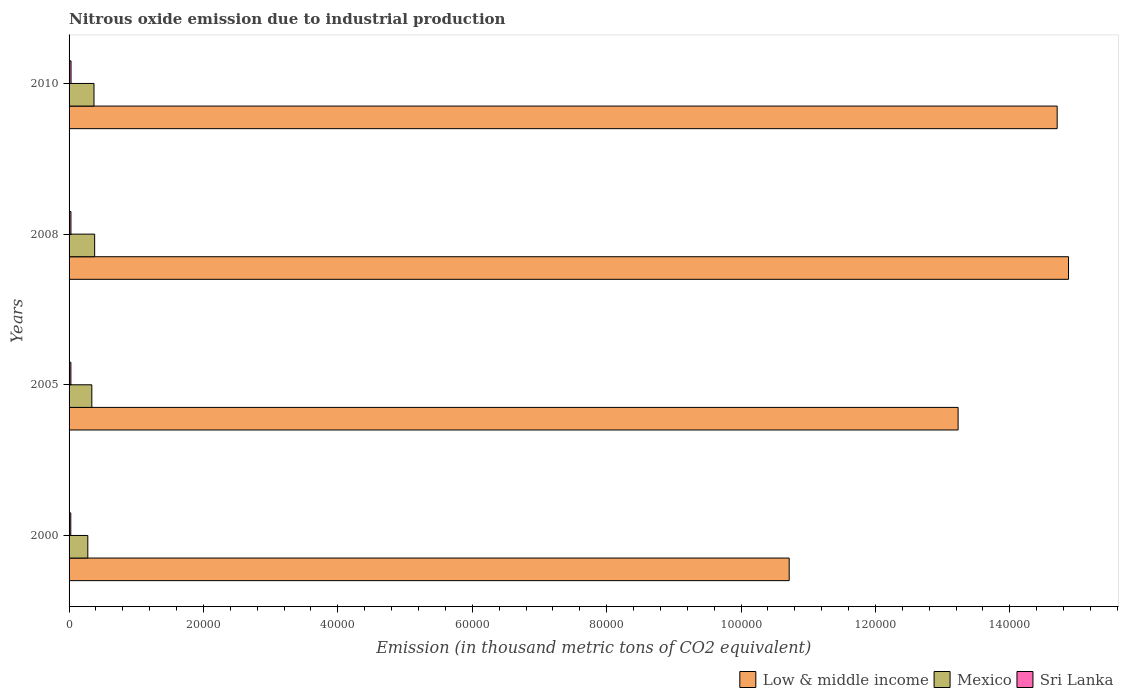Are the number of bars on each tick of the Y-axis equal?
Give a very brief answer. Yes. What is the label of the 2nd group of bars from the top?
Make the answer very short. 2008. What is the amount of nitrous oxide emitted in Mexico in 2010?
Provide a short and direct response. 3709.2. Across all years, what is the maximum amount of nitrous oxide emitted in Low & middle income?
Make the answer very short. 1.49e+05. Across all years, what is the minimum amount of nitrous oxide emitted in Sri Lanka?
Your response must be concise. 254. In which year was the amount of nitrous oxide emitted in Sri Lanka minimum?
Provide a short and direct response. 2000. What is the total amount of nitrous oxide emitted in Mexico in the graph?
Your answer should be compact. 1.37e+04. What is the difference between the amount of nitrous oxide emitted in Low & middle income in 2005 and the amount of nitrous oxide emitted in Mexico in 2008?
Provide a succinct answer. 1.28e+05. What is the average amount of nitrous oxide emitted in Mexico per year?
Your response must be concise. 3423.7. In the year 2000, what is the difference between the amount of nitrous oxide emitted in Low & middle income and amount of nitrous oxide emitted in Sri Lanka?
Give a very brief answer. 1.07e+05. In how many years, is the amount of nitrous oxide emitted in Mexico greater than 84000 thousand metric tons?
Your answer should be very brief. 0. What is the ratio of the amount of nitrous oxide emitted in Sri Lanka in 2000 to that in 2010?
Your answer should be compact. 0.87. Is the amount of nitrous oxide emitted in Low & middle income in 2000 less than that in 2008?
Your answer should be very brief. Yes. Is the difference between the amount of nitrous oxide emitted in Low & middle income in 2008 and 2010 greater than the difference between the amount of nitrous oxide emitted in Sri Lanka in 2008 and 2010?
Ensure brevity in your answer.  Yes. What is the difference between the highest and the second highest amount of nitrous oxide emitted in Mexico?
Keep it short and to the point. 99.5. What is the difference between the highest and the lowest amount of nitrous oxide emitted in Low & middle income?
Your response must be concise. 4.16e+04. Is the sum of the amount of nitrous oxide emitted in Sri Lanka in 2005 and 2010 greater than the maximum amount of nitrous oxide emitted in Low & middle income across all years?
Give a very brief answer. No. Are all the bars in the graph horizontal?
Offer a terse response. Yes. Does the graph contain any zero values?
Your answer should be very brief. No. Does the graph contain grids?
Make the answer very short. No. How many legend labels are there?
Your response must be concise. 3. What is the title of the graph?
Give a very brief answer. Nitrous oxide emission due to industrial production. Does "St. Martin (French part)" appear as one of the legend labels in the graph?
Keep it short and to the point. No. What is the label or title of the X-axis?
Keep it short and to the point. Emission (in thousand metric tons of CO2 equivalent). What is the label or title of the Y-axis?
Ensure brevity in your answer.  Years. What is the Emission (in thousand metric tons of CO2 equivalent) in Low & middle income in 2000?
Offer a very short reply. 1.07e+05. What is the Emission (in thousand metric tons of CO2 equivalent) of Mexico in 2000?
Your response must be concise. 2789.1. What is the Emission (in thousand metric tons of CO2 equivalent) of Sri Lanka in 2000?
Make the answer very short. 254. What is the Emission (in thousand metric tons of CO2 equivalent) of Low & middle income in 2005?
Keep it short and to the point. 1.32e+05. What is the Emission (in thousand metric tons of CO2 equivalent) of Mexico in 2005?
Keep it short and to the point. 3387.8. What is the Emission (in thousand metric tons of CO2 equivalent) in Sri Lanka in 2005?
Your response must be concise. 271.8. What is the Emission (in thousand metric tons of CO2 equivalent) of Low & middle income in 2008?
Give a very brief answer. 1.49e+05. What is the Emission (in thousand metric tons of CO2 equivalent) in Mexico in 2008?
Provide a short and direct response. 3808.7. What is the Emission (in thousand metric tons of CO2 equivalent) of Sri Lanka in 2008?
Your answer should be compact. 278.3. What is the Emission (in thousand metric tons of CO2 equivalent) in Low & middle income in 2010?
Give a very brief answer. 1.47e+05. What is the Emission (in thousand metric tons of CO2 equivalent) of Mexico in 2010?
Your response must be concise. 3709.2. What is the Emission (in thousand metric tons of CO2 equivalent) of Sri Lanka in 2010?
Give a very brief answer. 292.4. Across all years, what is the maximum Emission (in thousand metric tons of CO2 equivalent) of Low & middle income?
Offer a very short reply. 1.49e+05. Across all years, what is the maximum Emission (in thousand metric tons of CO2 equivalent) of Mexico?
Your answer should be very brief. 3808.7. Across all years, what is the maximum Emission (in thousand metric tons of CO2 equivalent) in Sri Lanka?
Your answer should be compact. 292.4. Across all years, what is the minimum Emission (in thousand metric tons of CO2 equivalent) in Low & middle income?
Your response must be concise. 1.07e+05. Across all years, what is the minimum Emission (in thousand metric tons of CO2 equivalent) in Mexico?
Your answer should be compact. 2789.1. Across all years, what is the minimum Emission (in thousand metric tons of CO2 equivalent) in Sri Lanka?
Offer a terse response. 254. What is the total Emission (in thousand metric tons of CO2 equivalent) of Low & middle income in the graph?
Offer a terse response. 5.35e+05. What is the total Emission (in thousand metric tons of CO2 equivalent) in Mexico in the graph?
Ensure brevity in your answer.  1.37e+04. What is the total Emission (in thousand metric tons of CO2 equivalent) of Sri Lanka in the graph?
Provide a succinct answer. 1096.5. What is the difference between the Emission (in thousand metric tons of CO2 equivalent) in Low & middle income in 2000 and that in 2005?
Provide a short and direct response. -2.51e+04. What is the difference between the Emission (in thousand metric tons of CO2 equivalent) in Mexico in 2000 and that in 2005?
Provide a succinct answer. -598.7. What is the difference between the Emission (in thousand metric tons of CO2 equivalent) of Sri Lanka in 2000 and that in 2005?
Make the answer very short. -17.8. What is the difference between the Emission (in thousand metric tons of CO2 equivalent) of Low & middle income in 2000 and that in 2008?
Provide a short and direct response. -4.16e+04. What is the difference between the Emission (in thousand metric tons of CO2 equivalent) of Mexico in 2000 and that in 2008?
Provide a succinct answer. -1019.6. What is the difference between the Emission (in thousand metric tons of CO2 equivalent) in Sri Lanka in 2000 and that in 2008?
Offer a terse response. -24.3. What is the difference between the Emission (in thousand metric tons of CO2 equivalent) in Low & middle income in 2000 and that in 2010?
Offer a very short reply. -3.99e+04. What is the difference between the Emission (in thousand metric tons of CO2 equivalent) in Mexico in 2000 and that in 2010?
Ensure brevity in your answer.  -920.1. What is the difference between the Emission (in thousand metric tons of CO2 equivalent) in Sri Lanka in 2000 and that in 2010?
Offer a terse response. -38.4. What is the difference between the Emission (in thousand metric tons of CO2 equivalent) of Low & middle income in 2005 and that in 2008?
Keep it short and to the point. -1.64e+04. What is the difference between the Emission (in thousand metric tons of CO2 equivalent) in Mexico in 2005 and that in 2008?
Ensure brevity in your answer.  -420.9. What is the difference between the Emission (in thousand metric tons of CO2 equivalent) in Sri Lanka in 2005 and that in 2008?
Keep it short and to the point. -6.5. What is the difference between the Emission (in thousand metric tons of CO2 equivalent) in Low & middle income in 2005 and that in 2010?
Your response must be concise. -1.47e+04. What is the difference between the Emission (in thousand metric tons of CO2 equivalent) of Mexico in 2005 and that in 2010?
Your answer should be compact. -321.4. What is the difference between the Emission (in thousand metric tons of CO2 equivalent) of Sri Lanka in 2005 and that in 2010?
Give a very brief answer. -20.6. What is the difference between the Emission (in thousand metric tons of CO2 equivalent) in Low & middle income in 2008 and that in 2010?
Give a very brief answer. 1688.4. What is the difference between the Emission (in thousand metric tons of CO2 equivalent) in Mexico in 2008 and that in 2010?
Offer a terse response. 99.5. What is the difference between the Emission (in thousand metric tons of CO2 equivalent) of Sri Lanka in 2008 and that in 2010?
Offer a terse response. -14.1. What is the difference between the Emission (in thousand metric tons of CO2 equivalent) in Low & middle income in 2000 and the Emission (in thousand metric tons of CO2 equivalent) in Mexico in 2005?
Give a very brief answer. 1.04e+05. What is the difference between the Emission (in thousand metric tons of CO2 equivalent) in Low & middle income in 2000 and the Emission (in thousand metric tons of CO2 equivalent) in Sri Lanka in 2005?
Give a very brief answer. 1.07e+05. What is the difference between the Emission (in thousand metric tons of CO2 equivalent) in Mexico in 2000 and the Emission (in thousand metric tons of CO2 equivalent) in Sri Lanka in 2005?
Offer a very short reply. 2517.3. What is the difference between the Emission (in thousand metric tons of CO2 equivalent) in Low & middle income in 2000 and the Emission (in thousand metric tons of CO2 equivalent) in Mexico in 2008?
Provide a succinct answer. 1.03e+05. What is the difference between the Emission (in thousand metric tons of CO2 equivalent) of Low & middle income in 2000 and the Emission (in thousand metric tons of CO2 equivalent) of Sri Lanka in 2008?
Offer a terse response. 1.07e+05. What is the difference between the Emission (in thousand metric tons of CO2 equivalent) of Mexico in 2000 and the Emission (in thousand metric tons of CO2 equivalent) of Sri Lanka in 2008?
Your answer should be compact. 2510.8. What is the difference between the Emission (in thousand metric tons of CO2 equivalent) of Low & middle income in 2000 and the Emission (in thousand metric tons of CO2 equivalent) of Mexico in 2010?
Offer a terse response. 1.03e+05. What is the difference between the Emission (in thousand metric tons of CO2 equivalent) of Low & middle income in 2000 and the Emission (in thousand metric tons of CO2 equivalent) of Sri Lanka in 2010?
Offer a very short reply. 1.07e+05. What is the difference between the Emission (in thousand metric tons of CO2 equivalent) in Mexico in 2000 and the Emission (in thousand metric tons of CO2 equivalent) in Sri Lanka in 2010?
Keep it short and to the point. 2496.7. What is the difference between the Emission (in thousand metric tons of CO2 equivalent) of Low & middle income in 2005 and the Emission (in thousand metric tons of CO2 equivalent) of Mexico in 2008?
Provide a short and direct response. 1.28e+05. What is the difference between the Emission (in thousand metric tons of CO2 equivalent) of Low & middle income in 2005 and the Emission (in thousand metric tons of CO2 equivalent) of Sri Lanka in 2008?
Provide a short and direct response. 1.32e+05. What is the difference between the Emission (in thousand metric tons of CO2 equivalent) of Mexico in 2005 and the Emission (in thousand metric tons of CO2 equivalent) of Sri Lanka in 2008?
Provide a succinct answer. 3109.5. What is the difference between the Emission (in thousand metric tons of CO2 equivalent) of Low & middle income in 2005 and the Emission (in thousand metric tons of CO2 equivalent) of Mexico in 2010?
Ensure brevity in your answer.  1.29e+05. What is the difference between the Emission (in thousand metric tons of CO2 equivalent) in Low & middle income in 2005 and the Emission (in thousand metric tons of CO2 equivalent) in Sri Lanka in 2010?
Your answer should be very brief. 1.32e+05. What is the difference between the Emission (in thousand metric tons of CO2 equivalent) of Mexico in 2005 and the Emission (in thousand metric tons of CO2 equivalent) of Sri Lanka in 2010?
Ensure brevity in your answer.  3095.4. What is the difference between the Emission (in thousand metric tons of CO2 equivalent) of Low & middle income in 2008 and the Emission (in thousand metric tons of CO2 equivalent) of Mexico in 2010?
Provide a succinct answer. 1.45e+05. What is the difference between the Emission (in thousand metric tons of CO2 equivalent) in Low & middle income in 2008 and the Emission (in thousand metric tons of CO2 equivalent) in Sri Lanka in 2010?
Offer a very short reply. 1.48e+05. What is the difference between the Emission (in thousand metric tons of CO2 equivalent) of Mexico in 2008 and the Emission (in thousand metric tons of CO2 equivalent) of Sri Lanka in 2010?
Provide a short and direct response. 3516.3. What is the average Emission (in thousand metric tons of CO2 equivalent) in Low & middle income per year?
Keep it short and to the point. 1.34e+05. What is the average Emission (in thousand metric tons of CO2 equivalent) of Mexico per year?
Your response must be concise. 3423.7. What is the average Emission (in thousand metric tons of CO2 equivalent) of Sri Lanka per year?
Offer a terse response. 274.12. In the year 2000, what is the difference between the Emission (in thousand metric tons of CO2 equivalent) of Low & middle income and Emission (in thousand metric tons of CO2 equivalent) of Mexico?
Provide a short and direct response. 1.04e+05. In the year 2000, what is the difference between the Emission (in thousand metric tons of CO2 equivalent) of Low & middle income and Emission (in thousand metric tons of CO2 equivalent) of Sri Lanka?
Give a very brief answer. 1.07e+05. In the year 2000, what is the difference between the Emission (in thousand metric tons of CO2 equivalent) of Mexico and Emission (in thousand metric tons of CO2 equivalent) of Sri Lanka?
Give a very brief answer. 2535.1. In the year 2005, what is the difference between the Emission (in thousand metric tons of CO2 equivalent) of Low & middle income and Emission (in thousand metric tons of CO2 equivalent) of Mexico?
Your answer should be very brief. 1.29e+05. In the year 2005, what is the difference between the Emission (in thousand metric tons of CO2 equivalent) of Low & middle income and Emission (in thousand metric tons of CO2 equivalent) of Sri Lanka?
Ensure brevity in your answer.  1.32e+05. In the year 2005, what is the difference between the Emission (in thousand metric tons of CO2 equivalent) in Mexico and Emission (in thousand metric tons of CO2 equivalent) in Sri Lanka?
Your answer should be compact. 3116. In the year 2008, what is the difference between the Emission (in thousand metric tons of CO2 equivalent) of Low & middle income and Emission (in thousand metric tons of CO2 equivalent) of Mexico?
Offer a terse response. 1.45e+05. In the year 2008, what is the difference between the Emission (in thousand metric tons of CO2 equivalent) of Low & middle income and Emission (in thousand metric tons of CO2 equivalent) of Sri Lanka?
Make the answer very short. 1.48e+05. In the year 2008, what is the difference between the Emission (in thousand metric tons of CO2 equivalent) in Mexico and Emission (in thousand metric tons of CO2 equivalent) in Sri Lanka?
Ensure brevity in your answer.  3530.4. In the year 2010, what is the difference between the Emission (in thousand metric tons of CO2 equivalent) in Low & middle income and Emission (in thousand metric tons of CO2 equivalent) in Mexico?
Provide a short and direct response. 1.43e+05. In the year 2010, what is the difference between the Emission (in thousand metric tons of CO2 equivalent) in Low & middle income and Emission (in thousand metric tons of CO2 equivalent) in Sri Lanka?
Your response must be concise. 1.47e+05. In the year 2010, what is the difference between the Emission (in thousand metric tons of CO2 equivalent) in Mexico and Emission (in thousand metric tons of CO2 equivalent) in Sri Lanka?
Your response must be concise. 3416.8. What is the ratio of the Emission (in thousand metric tons of CO2 equivalent) of Low & middle income in 2000 to that in 2005?
Provide a short and direct response. 0.81. What is the ratio of the Emission (in thousand metric tons of CO2 equivalent) of Mexico in 2000 to that in 2005?
Provide a succinct answer. 0.82. What is the ratio of the Emission (in thousand metric tons of CO2 equivalent) of Sri Lanka in 2000 to that in 2005?
Keep it short and to the point. 0.93. What is the ratio of the Emission (in thousand metric tons of CO2 equivalent) of Low & middle income in 2000 to that in 2008?
Keep it short and to the point. 0.72. What is the ratio of the Emission (in thousand metric tons of CO2 equivalent) of Mexico in 2000 to that in 2008?
Keep it short and to the point. 0.73. What is the ratio of the Emission (in thousand metric tons of CO2 equivalent) of Sri Lanka in 2000 to that in 2008?
Offer a very short reply. 0.91. What is the ratio of the Emission (in thousand metric tons of CO2 equivalent) of Low & middle income in 2000 to that in 2010?
Keep it short and to the point. 0.73. What is the ratio of the Emission (in thousand metric tons of CO2 equivalent) of Mexico in 2000 to that in 2010?
Ensure brevity in your answer.  0.75. What is the ratio of the Emission (in thousand metric tons of CO2 equivalent) in Sri Lanka in 2000 to that in 2010?
Make the answer very short. 0.87. What is the ratio of the Emission (in thousand metric tons of CO2 equivalent) of Low & middle income in 2005 to that in 2008?
Offer a very short reply. 0.89. What is the ratio of the Emission (in thousand metric tons of CO2 equivalent) in Mexico in 2005 to that in 2008?
Offer a terse response. 0.89. What is the ratio of the Emission (in thousand metric tons of CO2 equivalent) in Sri Lanka in 2005 to that in 2008?
Provide a succinct answer. 0.98. What is the ratio of the Emission (in thousand metric tons of CO2 equivalent) in Low & middle income in 2005 to that in 2010?
Offer a very short reply. 0.9. What is the ratio of the Emission (in thousand metric tons of CO2 equivalent) of Mexico in 2005 to that in 2010?
Give a very brief answer. 0.91. What is the ratio of the Emission (in thousand metric tons of CO2 equivalent) in Sri Lanka in 2005 to that in 2010?
Your response must be concise. 0.93. What is the ratio of the Emission (in thousand metric tons of CO2 equivalent) of Low & middle income in 2008 to that in 2010?
Ensure brevity in your answer.  1.01. What is the ratio of the Emission (in thousand metric tons of CO2 equivalent) of Mexico in 2008 to that in 2010?
Your response must be concise. 1.03. What is the ratio of the Emission (in thousand metric tons of CO2 equivalent) of Sri Lanka in 2008 to that in 2010?
Your response must be concise. 0.95. What is the difference between the highest and the second highest Emission (in thousand metric tons of CO2 equivalent) of Low & middle income?
Make the answer very short. 1688.4. What is the difference between the highest and the second highest Emission (in thousand metric tons of CO2 equivalent) in Mexico?
Make the answer very short. 99.5. What is the difference between the highest and the second highest Emission (in thousand metric tons of CO2 equivalent) in Sri Lanka?
Offer a terse response. 14.1. What is the difference between the highest and the lowest Emission (in thousand metric tons of CO2 equivalent) in Low & middle income?
Ensure brevity in your answer.  4.16e+04. What is the difference between the highest and the lowest Emission (in thousand metric tons of CO2 equivalent) in Mexico?
Your answer should be compact. 1019.6. What is the difference between the highest and the lowest Emission (in thousand metric tons of CO2 equivalent) in Sri Lanka?
Offer a very short reply. 38.4. 